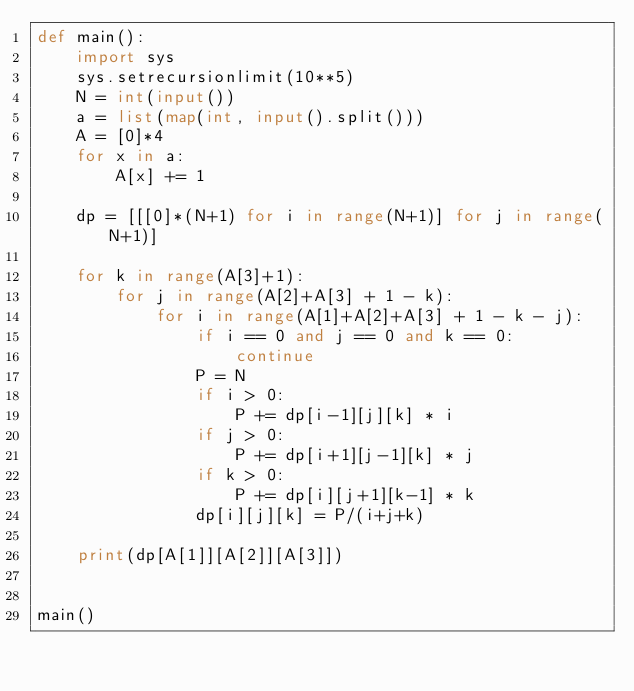Convert code to text. <code><loc_0><loc_0><loc_500><loc_500><_Python_>def main():
    import sys
    sys.setrecursionlimit(10**5)
    N = int(input())
    a = list(map(int, input().split()))
    A = [0]*4
    for x in a:
        A[x] += 1

    dp = [[[0]*(N+1) for i in range(N+1)] for j in range(N+1)]

    for k in range(A[3]+1):
        for j in range(A[2]+A[3] + 1 - k):
            for i in range(A[1]+A[2]+A[3] + 1 - k - j):
                if i == 0 and j == 0 and k == 0:
                    continue
                P = N
                if i > 0:
                    P += dp[i-1][j][k] * i
                if j > 0:
                    P += dp[i+1][j-1][k] * j
                if k > 0:
                    P += dp[i][j+1][k-1] * k
                dp[i][j][k] = P/(i+j+k)

    print(dp[A[1]][A[2]][A[3]])


main()
</code> 